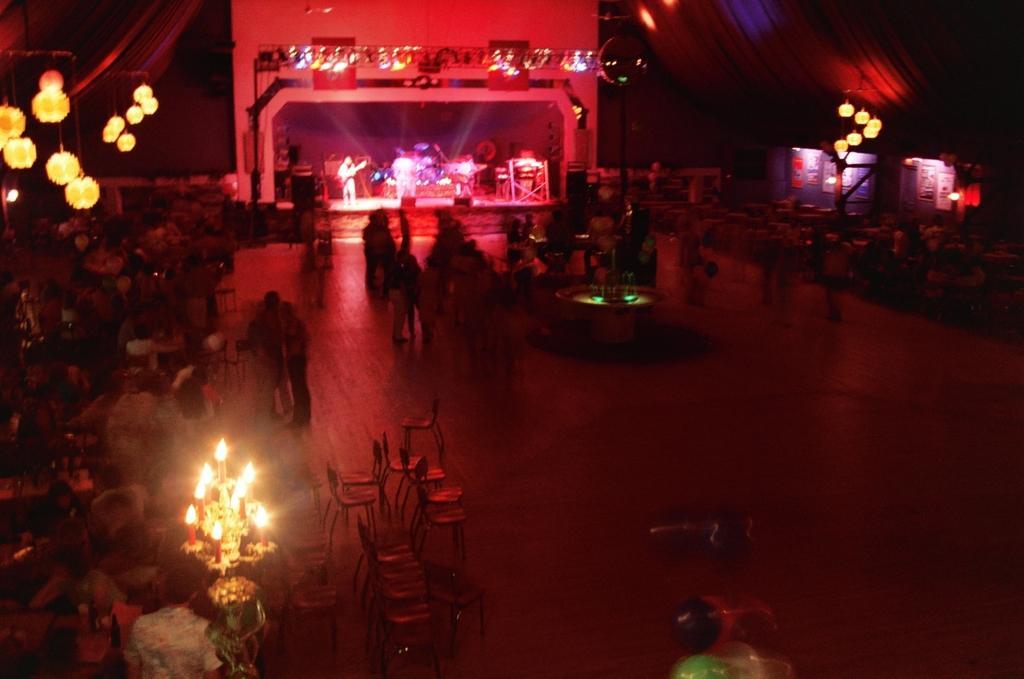How would you summarize this image in a sentence or two? In this image there are a group of people some of them are sitting on chairs, and also there are some tables and some of them are standing. In the center there are some people who are on stage, and they are playing some musical instruments and also there are some musical instruments. On the right side and left side there are some lights and also there are some curtains, at the bottom there is a floor. 